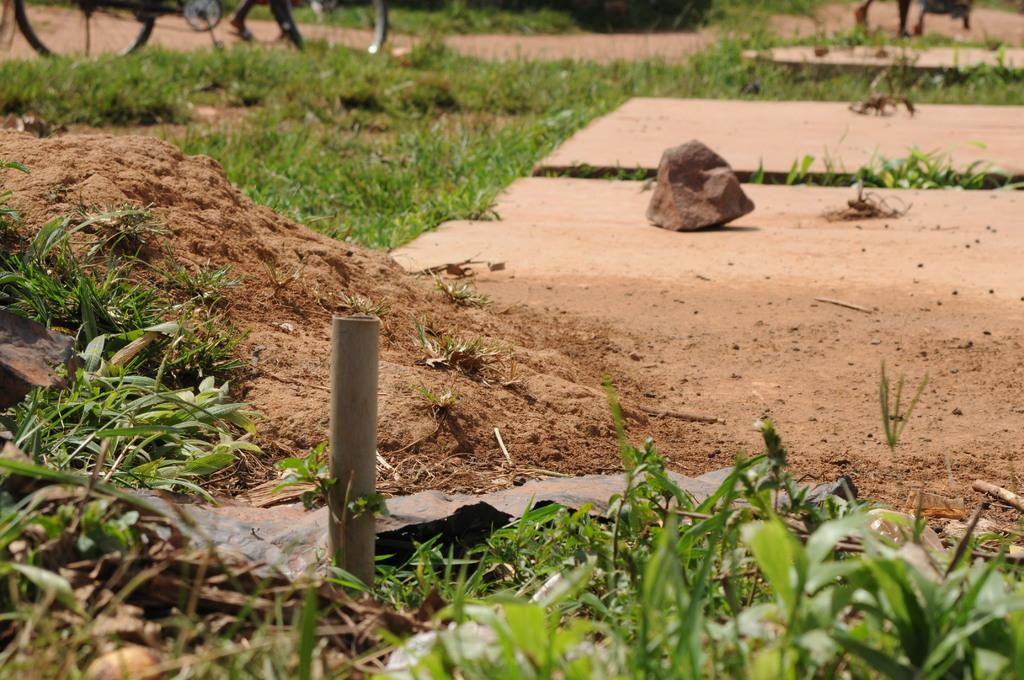What type of vegetation is visible in the image? There is green grass in the image. What structure can be seen in the image? There is a pole in the image. What natural element is present in the image? There is a rock in the image. What type of transportation is on the road in the image? There are vehicles on the road in the image. Can you tell me how many jellyfish are swimming in the grass in the image? There are no jellyfish present in the image; it features green grass. What type of caption is written on the rock in the image? There is no caption written on the rock in the image; it is a natural element. 